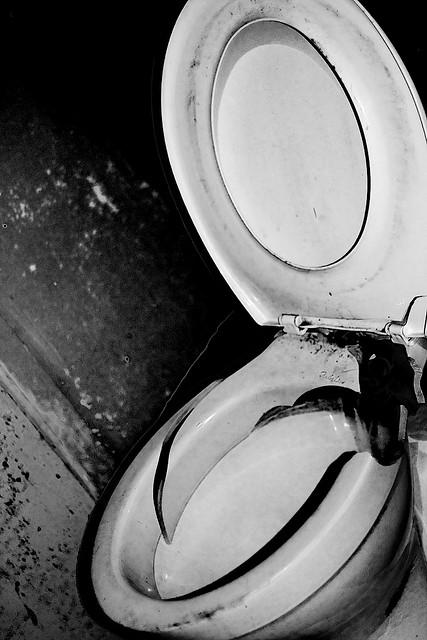What color is the toilet?
Give a very brief answer. White. Is the toilet intact?
Answer briefly. No. Is the toilet lid closed?
Concise answer only. No. 